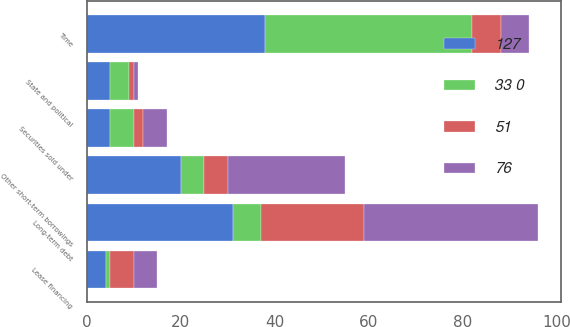Convert chart. <chart><loc_0><loc_0><loc_500><loc_500><stacked_bar_chart><ecel><fcel>State and political<fcel>Lease financing<fcel>Time<fcel>Securities sold under<fcel>Other short-term borrowings<fcel>Long-term debt<nl><fcel>33 0<fcel>4<fcel>1<fcel>44<fcel>5<fcel>5<fcel>6<nl><fcel>127<fcel>5<fcel>4<fcel>38<fcel>5<fcel>20<fcel>31<nl><fcel>76<fcel>1<fcel>5<fcel>6<fcel>5<fcel>25<fcel>37<nl><fcel>51<fcel>1<fcel>5<fcel>6<fcel>2<fcel>5<fcel>22<nl></chart> 